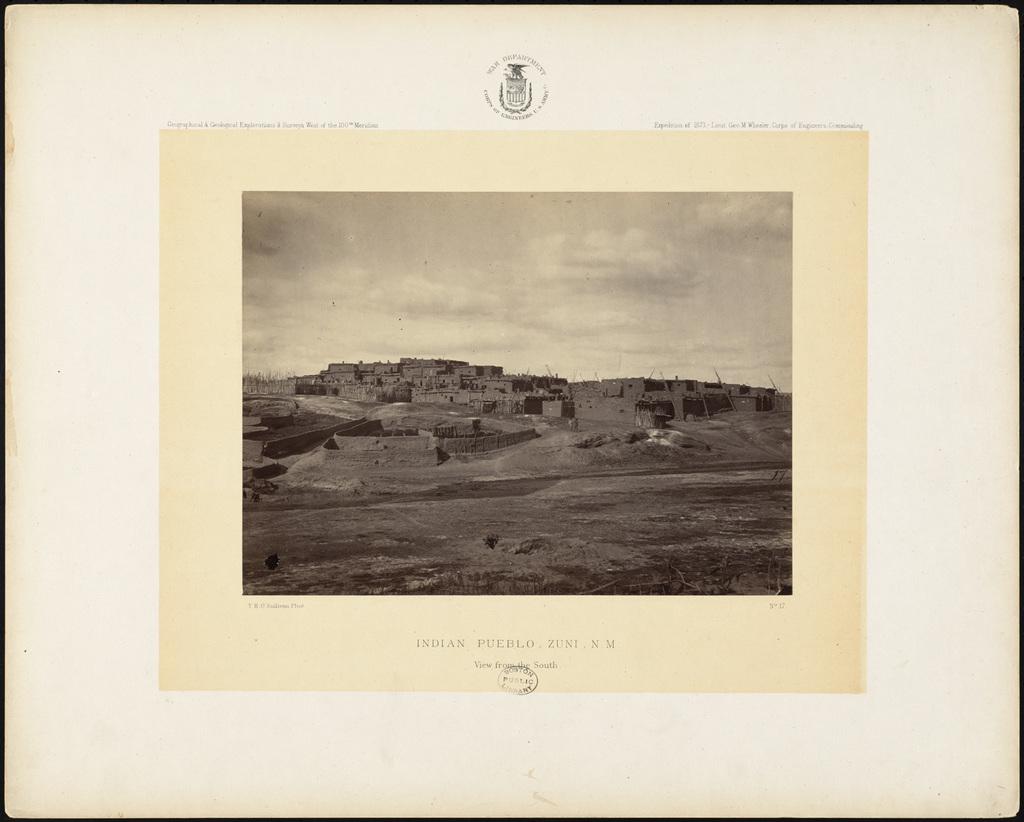What state is this photo from?
Provide a short and direct response. New mexico. 